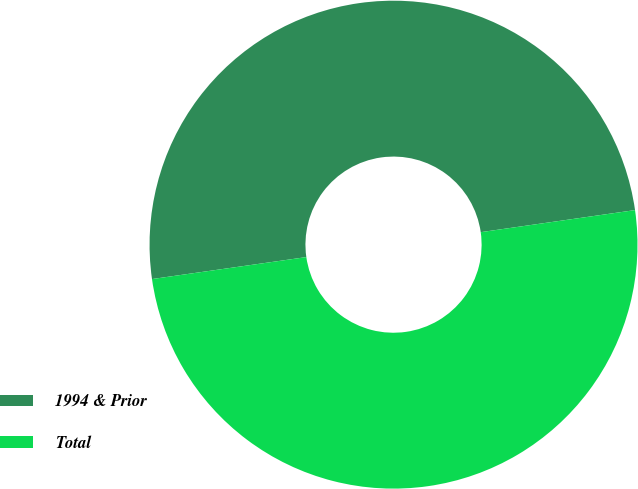<chart> <loc_0><loc_0><loc_500><loc_500><pie_chart><fcel>1994 & Prior<fcel>Total<nl><fcel>49.99%<fcel>50.01%<nl></chart> 